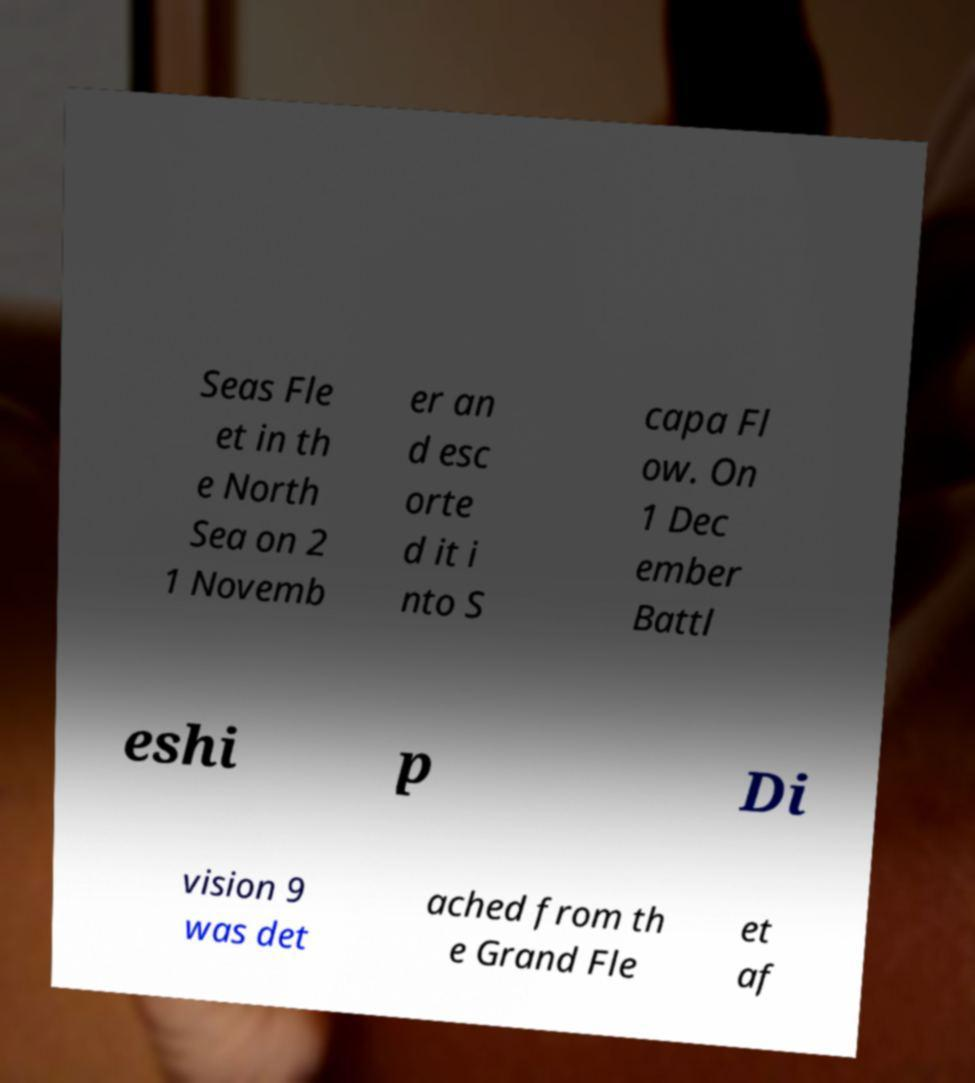Can you read and provide the text displayed in the image?This photo seems to have some interesting text. Can you extract and type it out for me? Seas Fle et in th e North Sea on 2 1 Novemb er an d esc orte d it i nto S capa Fl ow. On 1 Dec ember Battl eshi p Di vision 9 was det ached from th e Grand Fle et af 